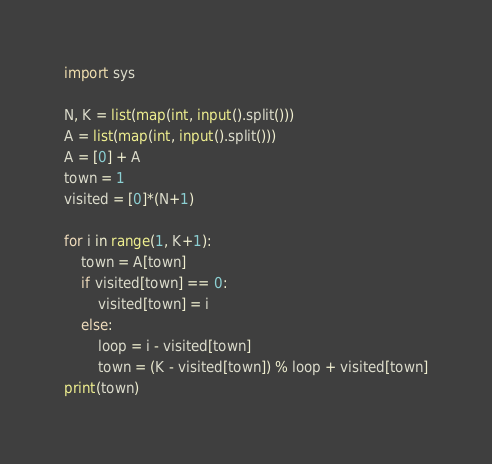Convert code to text. <code><loc_0><loc_0><loc_500><loc_500><_Python_>import sys

N, K = list(map(int, input().split()))
A = list(map(int, input().split()))
A = [0] + A
town = 1
visited = [0]*(N+1)

for i in range(1, K+1):
    town = A[town]
    if visited[town] == 0:
        visited[town] = i
    else:
        loop = i - visited[town]
        town = (K - visited[town]) % loop + visited[town]
print(town)</code> 